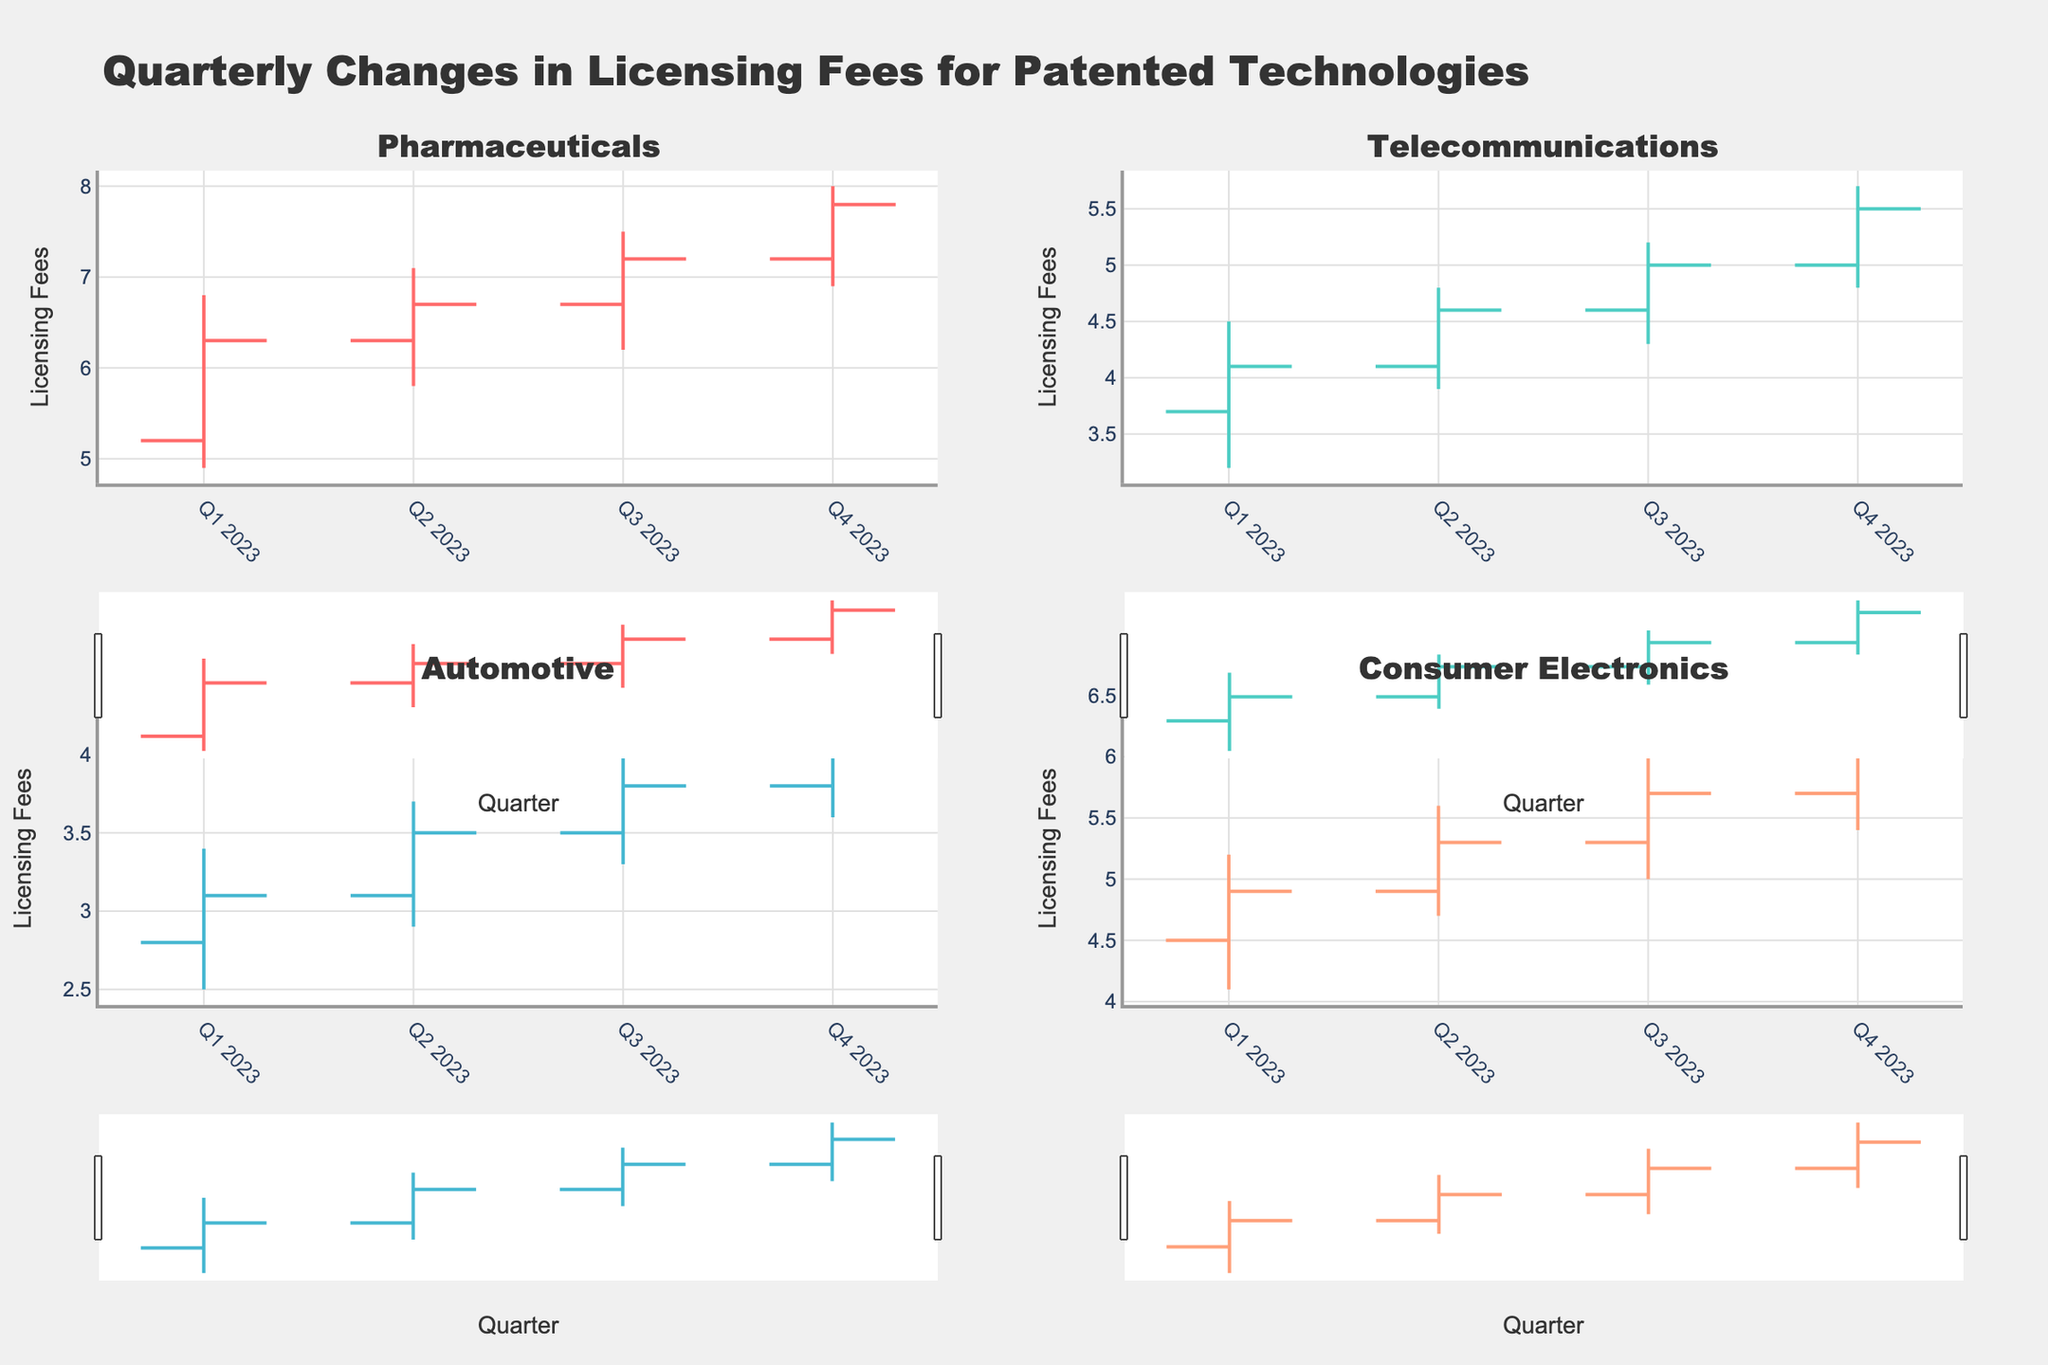What's the title of the figure? The title is displayed at the top of the figure. It reads "Quarterly Changes in Licensing Fees for Patented Technologies."
Answer: Quarterly Changes in Licensing Fees for Patented Technologies How many industries are compared in the figure? The figure contains four subplots, each representing a different industry.
Answer: Four Which industry had the highest closing fee in Q4 2023? Look at the closing prices for Q4 2023 in each subplot. The highest closing price in Q4 2023 is 7.8 for Pharmaceuticals.
Answer: Pharmaceuticals What is the range of the licensing fees for Telecommunications in Q1 2023? The range is the difference between the high and low fees. For Telecommunications in Q1 2023, the high is 4.5 and the low is 3.2. The range is 4.5 - 3.2 = 1.3.
Answer: 1.3 Compare the licensing fee increments from Q3 2023 to Q4 2023 for the Automotive and Consumer Electronics industries. Which one increased more? First, calculate the difference between closing fees for Q3 2023 and Q4 2023 for both industries. For Automotive, the difference is 4.1 - 3.8 = 0.3. For Consumer Electronics, the difference is 6.1 - 5.7 = 0.4. Consumer Electronics increased more.
Answer: Consumer Electronics In which quarters did the licensing fees for Pharmaceuticals show an increasing trend? In an increasing trend, the closing fee of a quarter is higher than the previous quarter. Check the closing fees for Pharmaceuticals: 6.3 (Q1 2023), 6.7 (Q2 2023), 7.2 (Q3 2023), 7.8 (Q4 2023). Increasing trends are observed in all quarters.
Answer: All Quarters Which industry showed the least volatility in Q2 2023? Volatility can be inferred from the difference between the high and low points. The differences are: Pharmaceuticals (7.1 - 5.8 = 1.3), Telecommunications (4.8 - 3.9 = 0.9), Automotive (3.7 - 2.9 = 0.8), Consumer Electronics (5.6 - 4.7 = 0.9). Automotive has the smallest difference.
Answer: Automotive What was the low licensing fee for Consumer Electronics in Q3 2023? In the subplot for Consumer Electronics, find the low value for Q3 2023.
Answer: 5.0 Compare the opening fees of Pharmaceuticals in Q1 2023 and Q4 2023. By how much did it increase? The opening fee in Q1 2023 for Pharmaceuticals is 5.2, and in Q4 2023, it is 7.2. The increase is 7.2 - 5.2 = 2.0.
Answer: 2.0 Describe the trend of licensing fees for Telecommunications from Q1 2023 to Q4 2023. Observe the closing prices for each quarter for Telecommunications. The trend starts at 4.1 (Q1 2023), increases to 4.6 (Q2 2023), rises to 5.0 (Q3 2023), and ends at 5.5 (Q4 2023). This shows a continuous upward trend throughout the year.
Answer: Continuous upward trend 